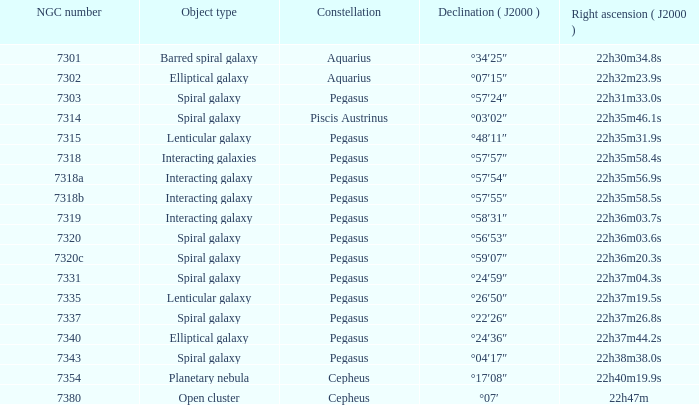I'm looking to parse the entire table for insights. Could you assist me with that? {'header': ['NGC number', 'Object type', 'Constellation', 'Declination ( J2000 )', 'Right ascension ( J2000 )'], 'rows': [['7301', 'Barred spiral galaxy', 'Aquarius', '°34′25″', '22h30m34.8s'], ['7302', 'Elliptical galaxy', 'Aquarius', '°07′15″', '22h32m23.9s'], ['7303', 'Spiral galaxy', 'Pegasus', '°57′24″', '22h31m33.0s'], ['7314', 'Spiral galaxy', 'Piscis Austrinus', '°03′02″', '22h35m46.1s'], ['7315', 'Lenticular galaxy', 'Pegasus', '°48′11″', '22h35m31.9s'], ['7318', 'Interacting galaxies', 'Pegasus', '°57′57″', '22h35m58.4s'], ['7318a', 'Interacting galaxy', 'Pegasus', '°57′54″', '22h35m56.9s'], ['7318b', 'Interacting galaxy', 'Pegasus', '°57′55″', '22h35m58.5s'], ['7319', 'Interacting galaxy', 'Pegasus', '°58′31″', '22h36m03.7s'], ['7320', 'Spiral galaxy', 'Pegasus', '°56′53″', '22h36m03.6s'], ['7320c', 'Spiral galaxy', 'Pegasus', '°59′07″', '22h36m20.3s'], ['7331', 'Spiral galaxy', 'Pegasus', '°24′59″', '22h37m04.3s'], ['7335', 'Lenticular galaxy', 'Pegasus', '°26′50″', '22h37m19.5s'], ['7337', 'Spiral galaxy', 'Pegasus', '°22′26″', '22h37m26.8s'], ['7340', 'Elliptical galaxy', 'Pegasus', '°24′36″', '22h37m44.2s'], ['7343', 'Spiral galaxy', 'Pegasus', '°04′17″', '22h38m38.0s'], ['7354', 'Planetary nebula', 'Cepheus', '°17′08″', '22h40m19.9s'], ['7380', 'Open cluster', 'Cepheus', '°07′', '22h47m']]} What is the declination of the spiral galaxy Pegasus with 7337 NGC °22′26″. 